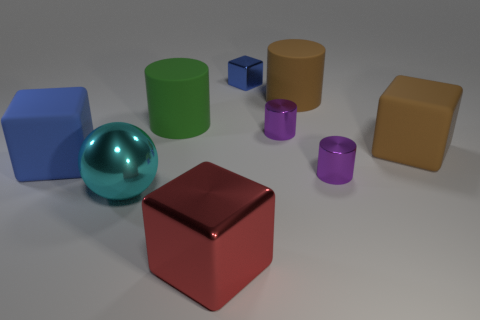Add 1 metal objects. How many objects exist? 10 Subtract all big cubes. How many cubes are left? 1 Subtract all brown cylinders. How many cylinders are left? 3 Add 5 green objects. How many green objects are left? 6 Add 6 cyan objects. How many cyan objects exist? 7 Subtract 0 purple spheres. How many objects are left? 9 Subtract all balls. How many objects are left? 8 Subtract 1 cubes. How many cubes are left? 3 Subtract all cyan cubes. Subtract all blue cylinders. How many cubes are left? 4 Subtract all brown cylinders. How many gray spheres are left? 0 